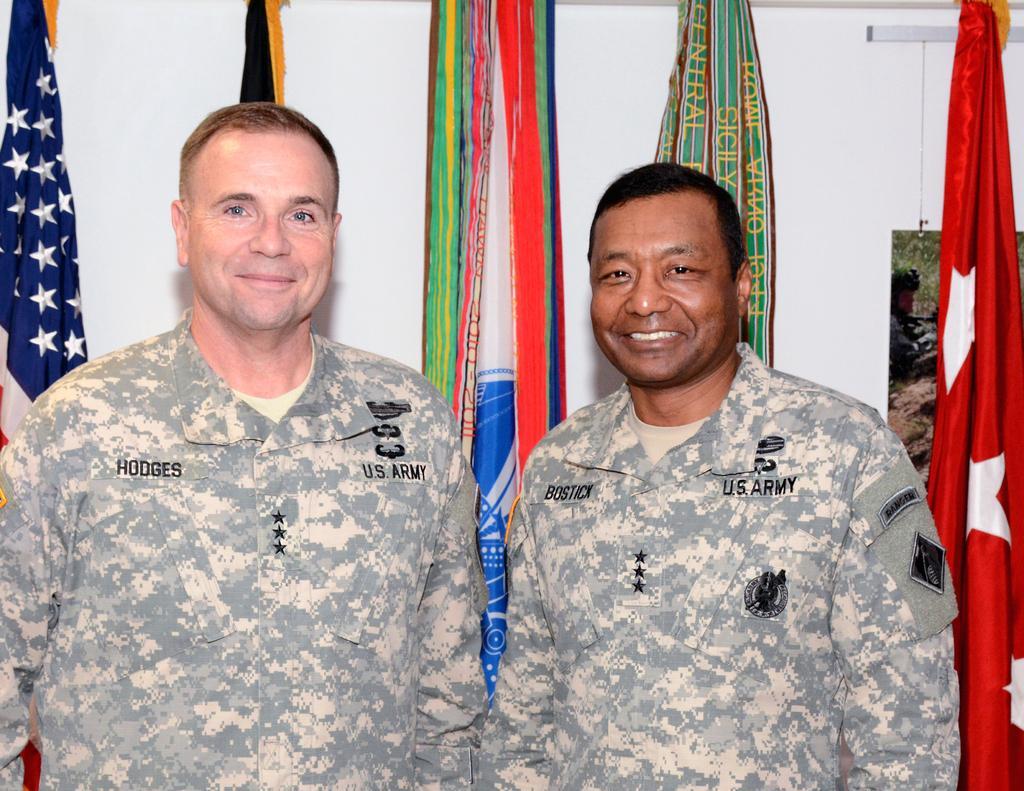Describe this image in one or two sentences. In this picture we can see two men, they both are smiling, behind to them we can find few flags and a wall. 